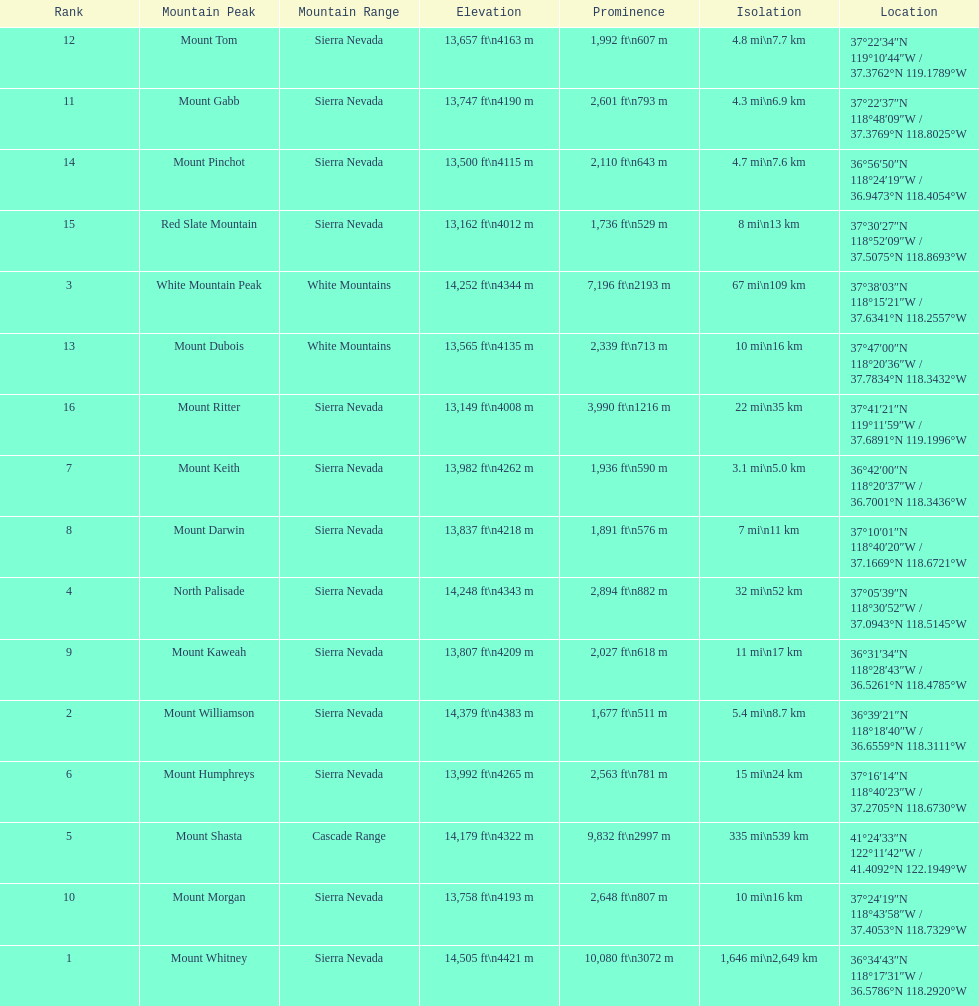In feet, what is the difference between the tallest peak and the 9th tallest peak in california? 698 ft. 